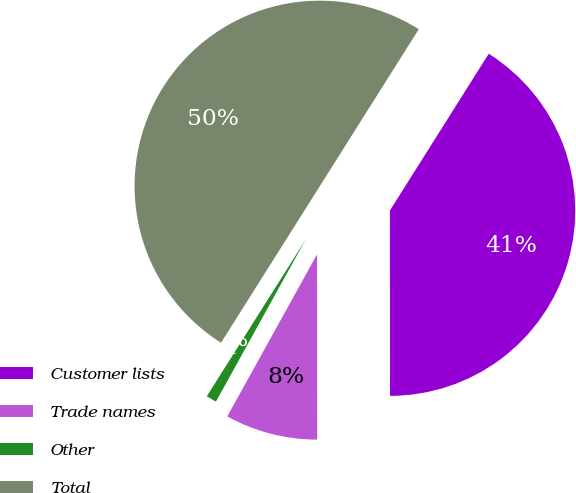Convert chart. <chart><loc_0><loc_0><loc_500><loc_500><pie_chart><fcel>Customer lists<fcel>Trade names<fcel>Other<fcel>Total<nl><fcel>41.04%<fcel>8.06%<fcel>0.91%<fcel>50.0%<nl></chart> 